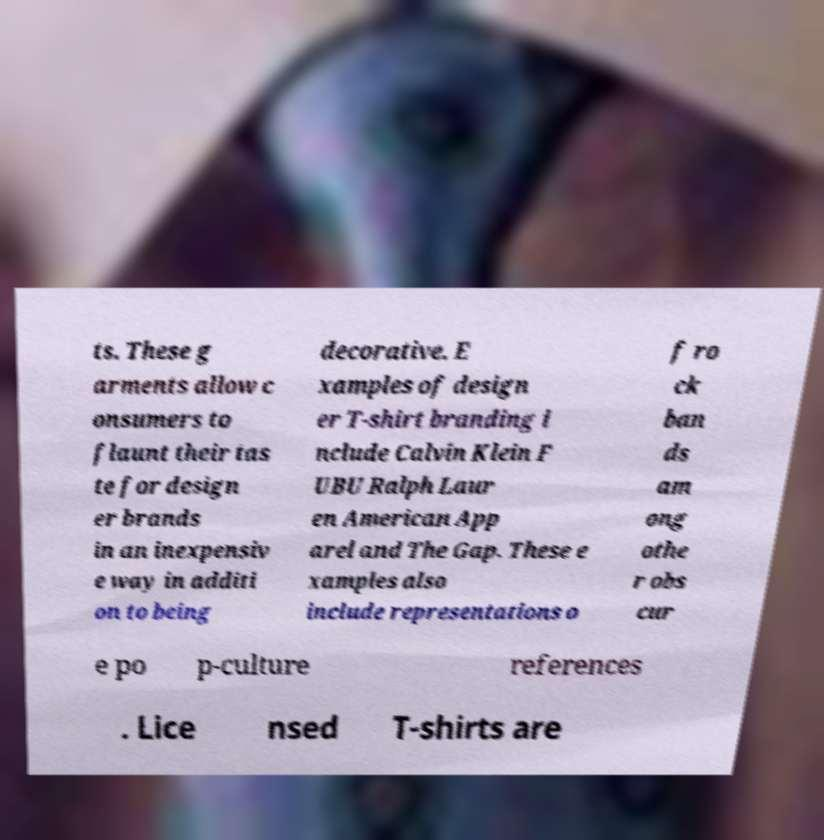Could you extract and type out the text from this image? ts. These g arments allow c onsumers to flaunt their tas te for design er brands in an inexpensiv e way in additi on to being decorative. E xamples of design er T-shirt branding i nclude Calvin Klein F UBU Ralph Laur en American App arel and The Gap. These e xamples also include representations o f ro ck ban ds am ong othe r obs cur e po p-culture references . Lice nsed T-shirts are 